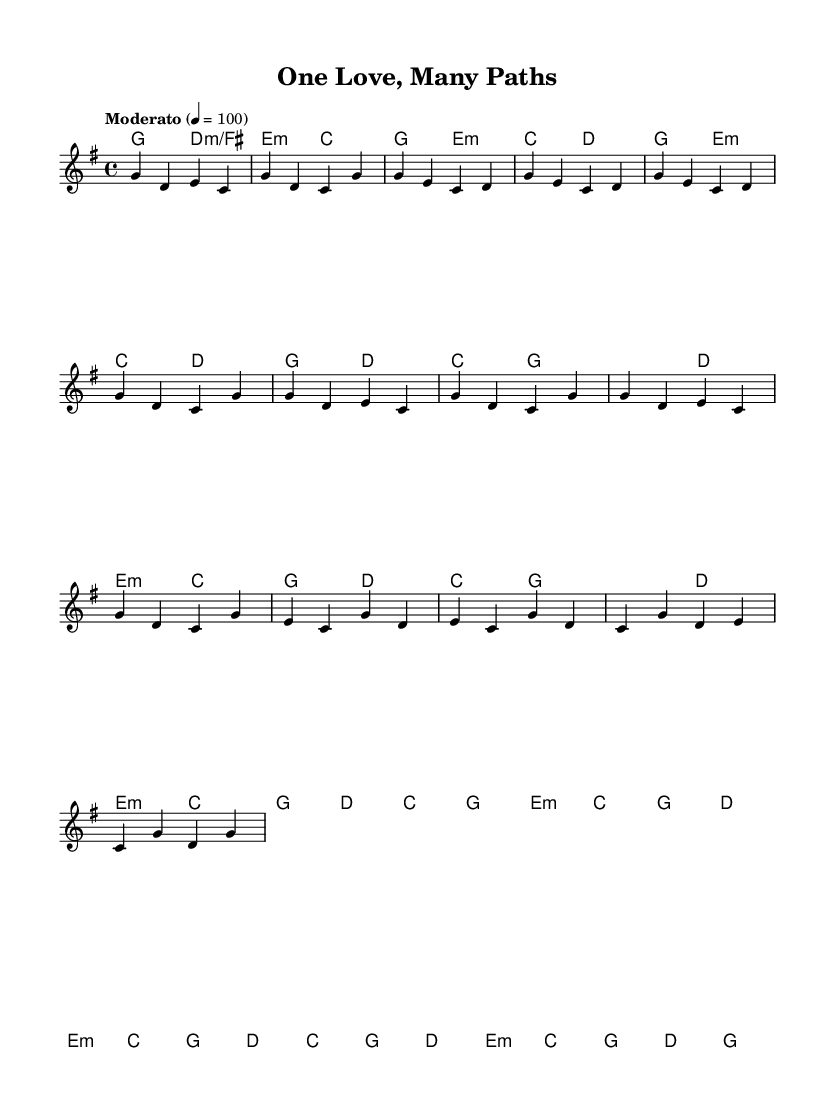What is the key signature of this music? The key signature is G major, which has one sharp (F#).
Answer: G major What is the time signature of this music? The time signature is 4/4, meaning there are four beats in each measure.
Answer: 4/4 What is the tempo of this music? The tempo is set to Moderato at quarter note = 100, indicating a moderate pace.
Answer: Moderato How many measures are in the chorus section? The chorus is composed of 4 measures, as indicated by the grouping of notes and rest in that section of the music.
Answer: 4 What is the function of the bridge in this piece? The bridge serves as a contrasting section that connects different parts of the song, providing variety to the overall structure.
Answer: Contrasting What type of harmony is mainly used in this piece? The harmony primarily employs triads and seventh chords, typical of folk music, creating a rich texture to accompany the melody.
Answer: Triads What is the tonal center of the melody in the chorus? The tonal center of the melody in the chorus predominantly revolves around the note G, which is the tonic of G major.
Answer: G 